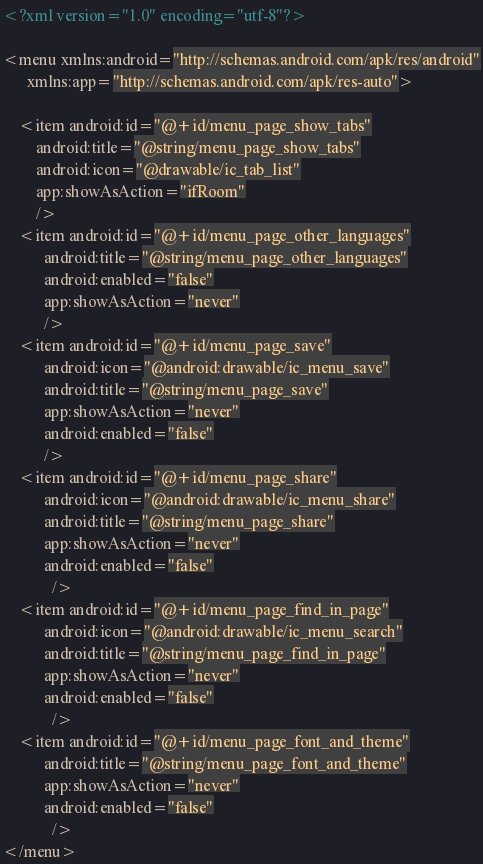<code> <loc_0><loc_0><loc_500><loc_500><_XML_><?xml version="1.0" encoding="utf-8"?>

<menu xmlns:android="http://schemas.android.com/apk/res/android"
      xmlns:app="http://schemas.android.com/apk/res-auto">

    <item android:id="@+id/menu_page_show_tabs"
        android:title="@string/menu_page_show_tabs"
        android:icon="@drawable/ic_tab_list"
        app:showAsAction="ifRoom"
        />
    <item android:id="@+id/menu_page_other_languages"
          android:title="@string/menu_page_other_languages"
          android:enabled="false"
          app:showAsAction="never"
          />
    <item android:id="@+id/menu_page_save"
          android:icon="@android:drawable/ic_menu_save"
          android:title="@string/menu_page_save"
          app:showAsAction="never"
          android:enabled="false"
          />
    <item android:id="@+id/menu_page_share"
          android:icon="@android:drawable/ic_menu_share"
          android:title="@string/menu_page_share"
          app:showAsAction="never"
          android:enabled="false"
            />
    <item android:id="@+id/menu_page_find_in_page"
          android:icon="@android:drawable/ic_menu_search"
          android:title="@string/menu_page_find_in_page"
          app:showAsAction="never"
          android:enabled="false"
            />
    <item android:id="@+id/menu_page_font_and_theme"
          android:title="@string/menu_page_font_and_theme"
          app:showAsAction="never"
          android:enabled="false"
            />
</menu></code> 